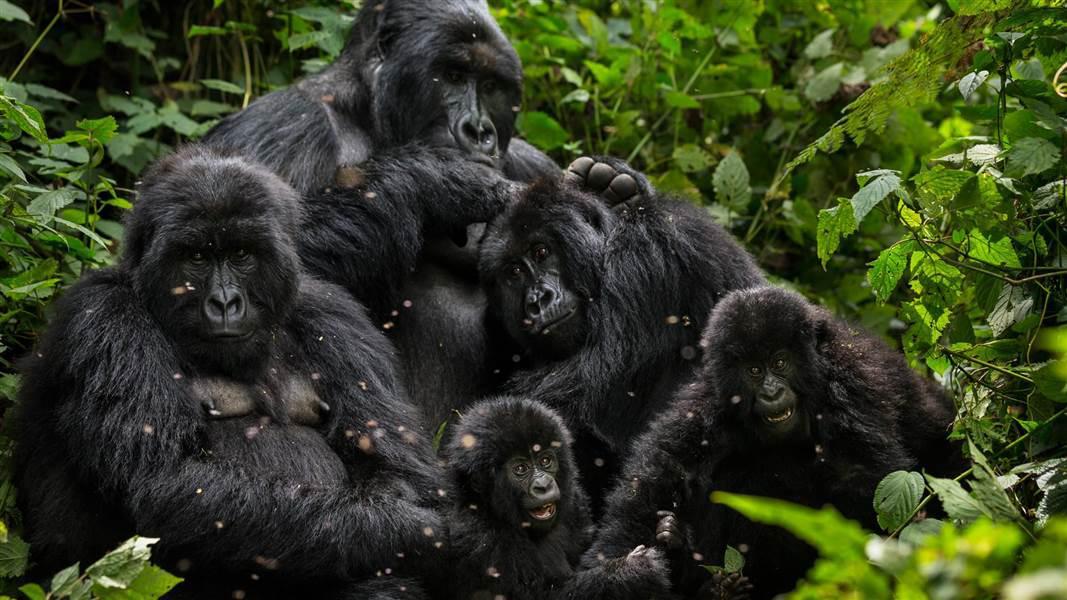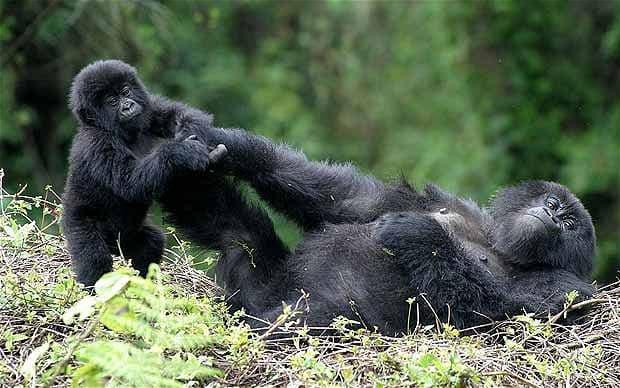The first image is the image on the left, the second image is the image on the right. Given the left and right images, does the statement "There are no more than six gorillas in total." hold true? Answer yes or no. No. The first image is the image on the left, the second image is the image on the right. Examine the images to the left and right. Is the description "The right image contains no more than three gorillas and includes a furry young gorilla, and the left image shows a close family group of gorillas facing forward." accurate? Answer yes or no. Yes. 